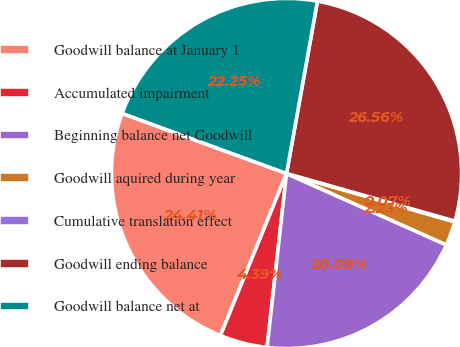Convert chart to OTSL. <chart><loc_0><loc_0><loc_500><loc_500><pie_chart><fcel>Goodwill balance at January 1<fcel>Accumulated impairment<fcel>Beginning balance net Goodwill<fcel>Goodwill aquired during year<fcel>Cumulative translation effect<fcel>Goodwill ending balance<fcel>Goodwill balance net at<nl><fcel>24.41%<fcel>4.39%<fcel>20.09%<fcel>2.23%<fcel>0.07%<fcel>26.56%<fcel>22.25%<nl></chart> 